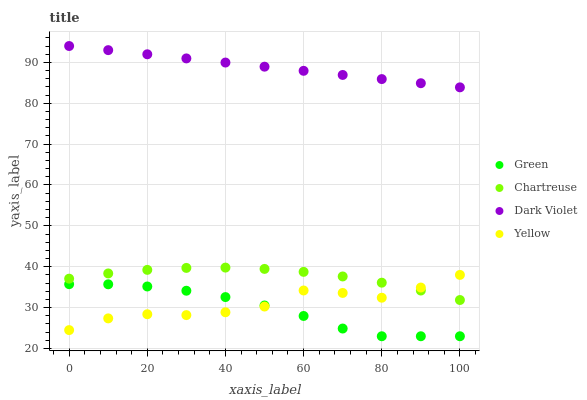Does Green have the minimum area under the curve?
Answer yes or no. Yes. Does Dark Violet have the maximum area under the curve?
Answer yes or no. Yes. Does Yellow have the minimum area under the curve?
Answer yes or no. No. Does Yellow have the maximum area under the curve?
Answer yes or no. No. Is Dark Violet the smoothest?
Answer yes or no. Yes. Is Yellow the roughest?
Answer yes or no. Yes. Is Green the smoothest?
Answer yes or no. No. Is Green the roughest?
Answer yes or no. No. Does Green have the lowest value?
Answer yes or no. Yes. Does Yellow have the lowest value?
Answer yes or no. No. Does Dark Violet have the highest value?
Answer yes or no. Yes. Does Yellow have the highest value?
Answer yes or no. No. Is Green less than Dark Violet?
Answer yes or no. Yes. Is Dark Violet greater than Green?
Answer yes or no. Yes. Does Chartreuse intersect Yellow?
Answer yes or no. Yes. Is Chartreuse less than Yellow?
Answer yes or no. No. Is Chartreuse greater than Yellow?
Answer yes or no. No. Does Green intersect Dark Violet?
Answer yes or no. No. 